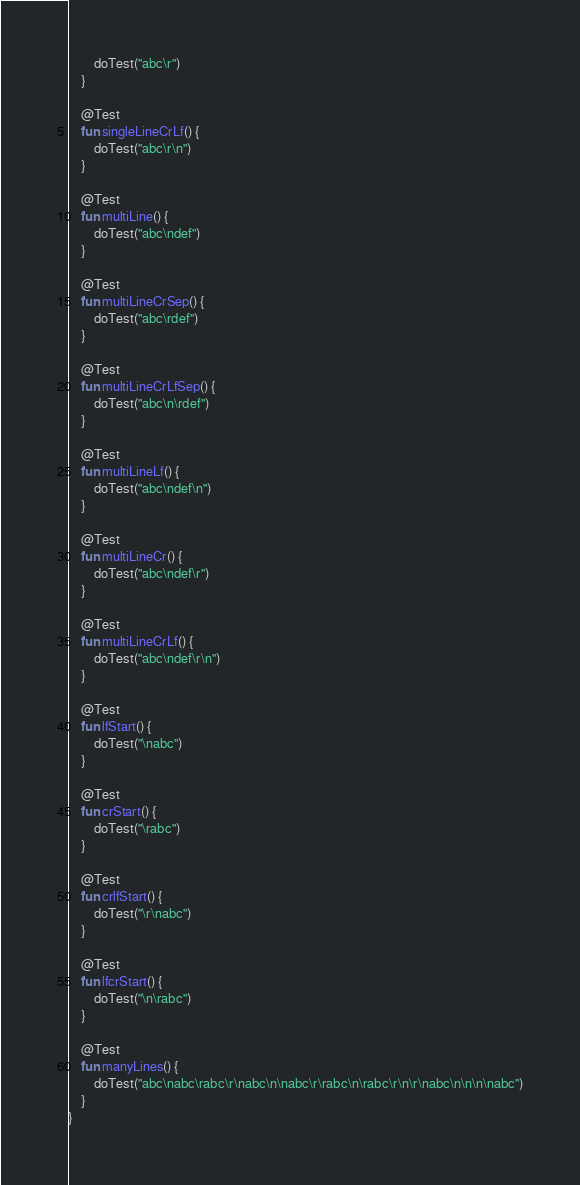Convert code to text. <code><loc_0><loc_0><loc_500><loc_500><_Kotlin_>        doTest("abc\r")
    }

    @Test
    fun singleLineCrLf() {
        doTest("abc\r\n")
    }

    @Test
    fun multiLine() {
        doTest("abc\ndef")
    }

    @Test
    fun multiLineCrSep() {
        doTest("abc\rdef")
    }

    @Test
    fun multiLineCrLfSep() {
        doTest("abc\n\rdef")
    }

    @Test
    fun multiLineLf() {
        doTest("abc\ndef\n")
    }

    @Test
    fun multiLineCr() {
        doTest("abc\ndef\r")
    }

    @Test
    fun multiLineCrLf() {
        doTest("abc\ndef\r\n")
    }

    @Test
    fun lfStart() {
        doTest("\nabc")
    }

    @Test
    fun crStart() {
        doTest("\rabc")
    }

    @Test
    fun crlfStart() {
        doTest("\r\nabc")
    }

    @Test
    fun lfcrStart() {
        doTest("\n\rabc")
    }

    @Test
    fun manyLines() {
        doTest("abc\nabc\rabc\r\nabc\n\nabc\r\rabc\n\rabc\r\n\r\nabc\n\n\n\nabc")
    }
}</code> 